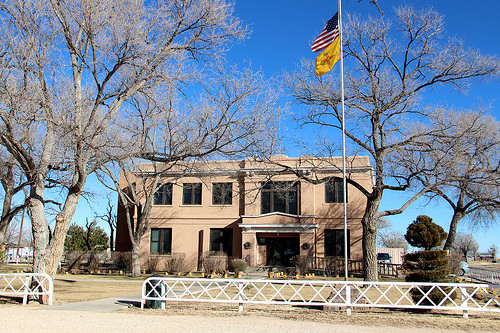<image>
Can you confirm if the flag post is on the building? No. The flag post is not positioned on the building. They may be near each other, but the flag post is not supported by or resting on top of the building. 